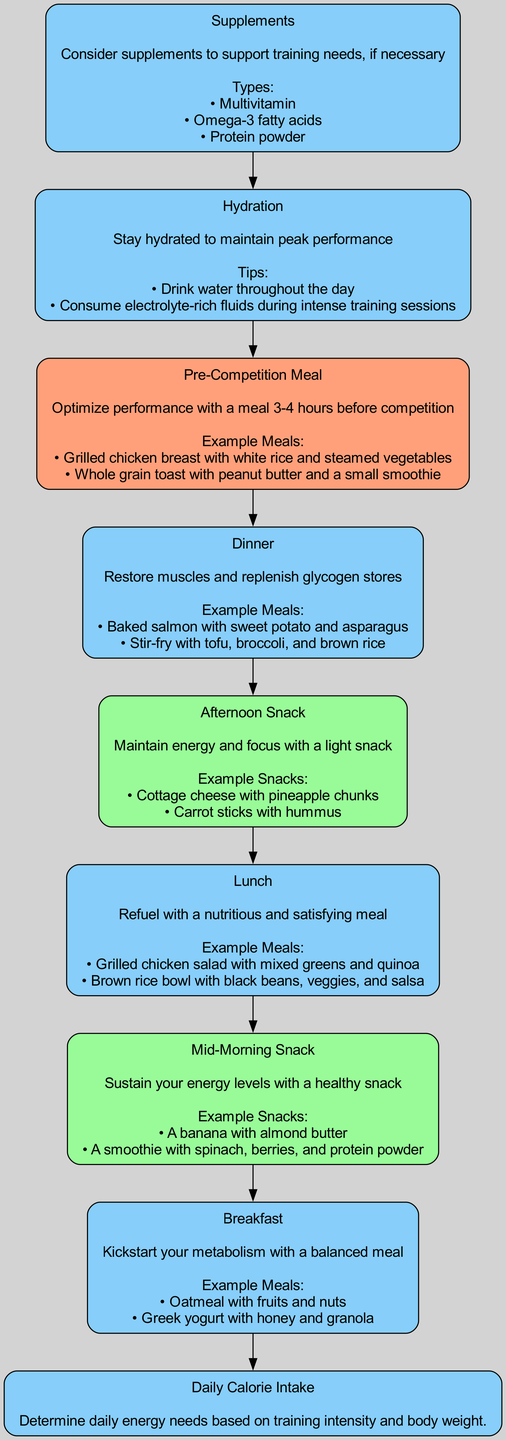What is the starting point of the nutrition plan? The diagram begins with "Daily Calorie Intake" at the bottom, which is the first step in the nutrition plan for high jumpers.
Answer: Daily Calorie Intake How many main meal nodes are there in the diagram? The diagram lists five main meal nodes: Breakfast, Lunch, Dinner, Afternoon Snack, and Pre-Competition Meal. Therefore, the total is counted as five.
Answer: Five What is the main fiber source suggested in breakfast examples? In the breakfast examples, oatmeal with fruits and nuts is a strong source of fiber mentioned, which contributes to digestive health.
Answer: Oatmeal What type of improvement should occur through proper hydration? The diagram suggests that proper hydration will help maintain peak performance, which is critical for athletes during training and competitions.
Answer: Peak Performance What is the final node in the flow chart? The last node in the flow chart, which concludes the nutritional instruction flow, is "Hydration." This indicates the significance of staying hydrated after all meals and snacks.
Answer: Hydration What is the percentage distribution of carbohydrates in the daily calorie intake? According to the nutritional overview, carbohydrates constitute 55% of the daily calorie intake, which is important for energy needs in high jumpers.
Answer: 55% What should you consume as a pre-competition meal? A suggested pre-competition meal could be grilled chicken breast with white rice and steamed vegetables, which provides an excellent balance for energy and recovery.
Answer: Grilled chicken breast with white rice and steamed vegetables Which node emphasizes the importance of supplements? The "Supplements" node emphasizes this need, highlighting specific types like multivitamin and omega-3 fatty acids. This ensures athletes meet their nutrient requirements.
Answer: Supplements Why is it important to have a mid-morning snack? The diagram recommends a mid-morning snack to sustain energy levels, indicating this time is critical for maintaining consistent energy throughout the training session.
Answer: Sustain energy levels 